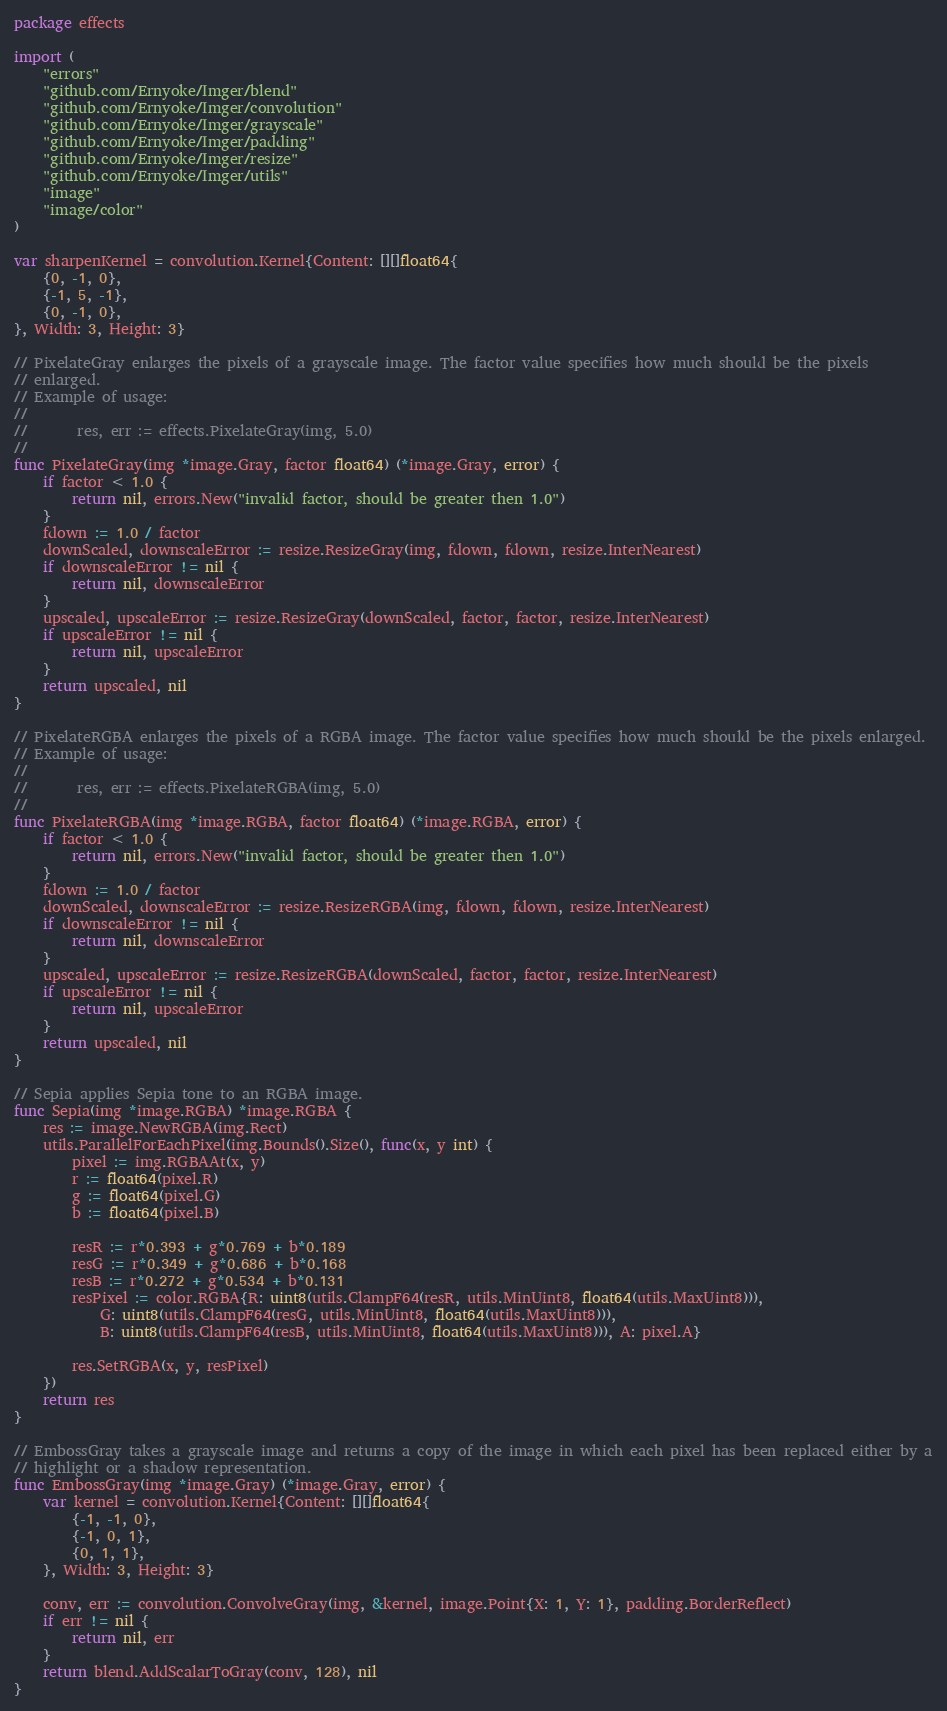Convert code to text. <code><loc_0><loc_0><loc_500><loc_500><_Go_>package effects

import (
	"errors"
	"github.com/Ernyoke/Imger/blend"
	"github.com/Ernyoke/Imger/convolution"
	"github.com/Ernyoke/Imger/grayscale"
	"github.com/Ernyoke/Imger/padding"
	"github.com/Ernyoke/Imger/resize"
	"github.com/Ernyoke/Imger/utils"
	"image"
	"image/color"
)

var sharpenKernel = convolution.Kernel{Content: [][]float64{
	{0, -1, 0},
	{-1, 5, -1},
	{0, -1, 0},
}, Width: 3, Height: 3}

// PixelateGray enlarges the pixels of a grayscale image. The factor value specifies how much should be the pixels
// enlarged.
// Example of usage:
//
//		 res, err := effects.PixelateGray(img, 5.0)
//
func PixelateGray(img *image.Gray, factor float64) (*image.Gray, error) {
	if factor < 1.0 {
		return nil, errors.New("invalid factor, should be greater then 1.0")
	}
	fdown := 1.0 / factor
	downScaled, downscaleError := resize.ResizeGray(img, fdown, fdown, resize.InterNearest)
	if downscaleError != nil {
		return nil, downscaleError
	}
	upscaled, upscaleError := resize.ResizeGray(downScaled, factor, factor, resize.InterNearest)
	if upscaleError != nil {
		return nil, upscaleError
	}
	return upscaled, nil
}

// PixelateRGBA enlarges the pixels of a RGBA image. The factor value specifies how much should be the pixels enlarged.
// Example of usage:
//
//		 res, err := effects.PixelateRGBA(img, 5.0)
//
func PixelateRGBA(img *image.RGBA, factor float64) (*image.RGBA, error) {
	if factor < 1.0 {
		return nil, errors.New("invalid factor, should be greater then 1.0")
	}
	fdown := 1.0 / factor
	downScaled, downscaleError := resize.ResizeRGBA(img, fdown, fdown, resize.InterNearest)
	if downscaleError != nil {
		return nil, downscaleError
	}
	upscaled, upscaleError := resize.ResizeRGBA(downScaled, factor, factor, resize.InterNearest)
	if upscaleError != nil {
		return nil, upscaleError
	}
	return upscaled, nil
}

// Sepia applies Sepia tone to an RGBA image.
func Sepia(img *image.RGBA) *image.RGBA {
	res := image.NewRGBA(img.Rect)
	utils.ParallelForEachPixel(img.Bounds().Size(), func(x, y int) {
		pixel := img.RGBAAt(x, y)
		r := float64(pixel.R)
		g := float64(pixel.G)
		b := float64(pixel.B)

		resR := r*0.393 + g*0.769 + b*0.189
		resG := r*0.349 + g*0.686 + b*0.168
		resB := r*0.272 + g*0.534 + b*0.131
		resPixel := color.RGBA{R: uint8(utils.ClampF64(resR, utils.MinUint8, float64(utils.MaxUint8))),
			G: uint8(utils.ClampF64(resG, utils.MinUint8, float64(utils.MaxUint8))),
			B: uint8(utils.ClampF64(resB, utils.MinUint8, float64(utils.MaxUint8))), A: pixel.A}

		res.SetRGBA(x, y, resPixel)
	})
	return res
}

// EmbossGray takes a grayscale image and returns a copy of the image in which each pixel has been replaced either by a
// highlight or a shadow representation.
func EmbossGray(img *image.Gray) (*image.Gray, error) {
	var kernel = convolution.Kernel{Content: [][]float64{
		{-1, -1, 0},
		{-1, 0, 1},
		{0, 1, 1},
	}, Width: 3, Height: 3}

	conv, err := convolution.ConvolveGray(img, &kernel, image.Point{X: 1, Y: 1}, padding.BorderReflect)
	if err != nil {
		return nil, err
	}
	return blend.AddScalarToGray(conv, 128), nil
}
</code> 